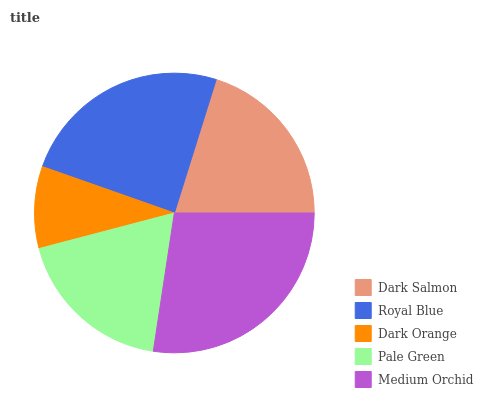Is Dark Orange the minimum?
Answer yes or no. Yes. Is Medium Orchid the maximum?
Answer yes or no. Yes. Is Royal Blue the minimum?
Answer yes or no. No. Is Royal Blue the maximum?
Answer yes or no. No. Is Royal Blue greater than Dark Salmon?
Answer yes or no. Yes. Is Dark Salmon less than Royal Blue?
Answer yes or no. Yes. Is Dark Salmon greater than Royal Blue?
Answer yes or no. No. Is Royal Blue less than Dark Salmon?
Answer yes or no. No. Is Dark Salmon the high median?
Answer yes or no. Yes. Is Dark Salmon the low median?
Answer yes or no. Yes. Is Royal Blue the high median?
Answer yes or no. No. Is Royal Blue the low median?
Answer yes or no. No. 